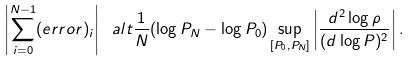Convert formula to latex. <formula><loc_0><loc_0><loc_500><loc_500>\left | \sum _ { i = 0 } ^ { N - 1 } ( e r r o r ) _ { i } \right | \ a l t \frac { 1 } { N } ( \log P _ { N } - \log P _ { 0 } ) \sup _ { [ P _ { 0 } , P _ { N } ] } \left | \frac { d ^ { 2 } \log \rho } { ( d \log P ) ^ { 2 } } \right | .</formula> 